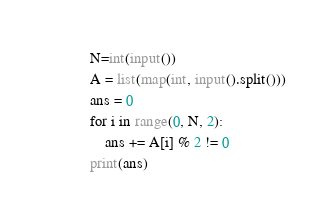Convert code to text. <code><loc_0><loc_0><loc_500><loc_500><_Python_>N=int(input())
A = list(map(int, input().split()))
ans = 0
for i in range(0, N, 2):
    ans += A[i] % 2 != 0
print(ans)
</code> 